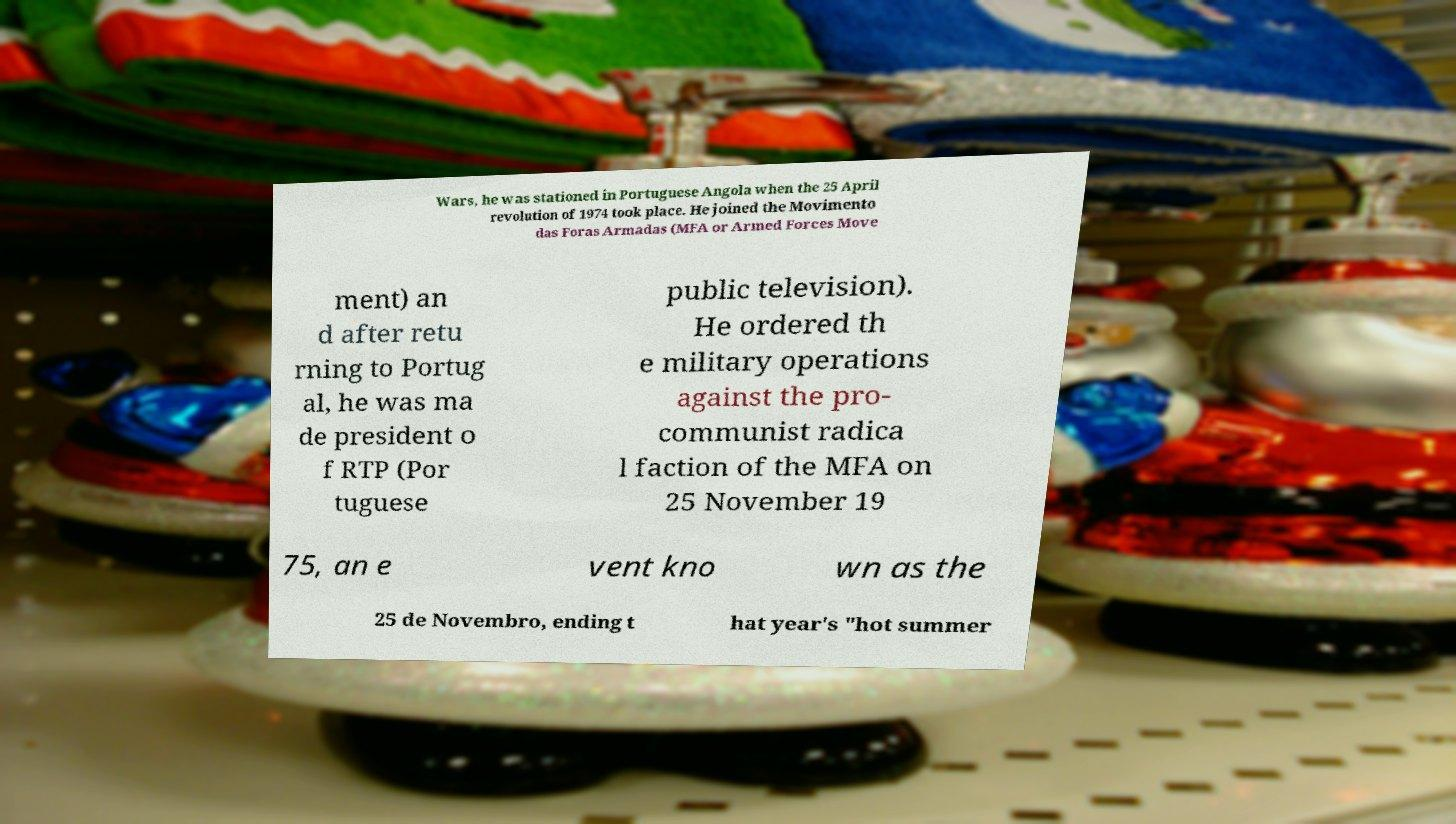For documentation purposes, I need the text within this image transcribed. Could you provide that? Wars, he was stationed in Portuguese Angola when the 25 April revolution of 1974 took place. He joined the Movimento das Foras Armadas (MFA or Armed Forces Move ment) an d after retu rning to Portug al, he was ma de president o f RTP (Por tuguese public television). He ordered th e military operations against the pro- communist radica l faction of the MFA on 25 November 19 75, an e vent kno wn as the 25 de Novembro, ending t hat year's "hot summer 